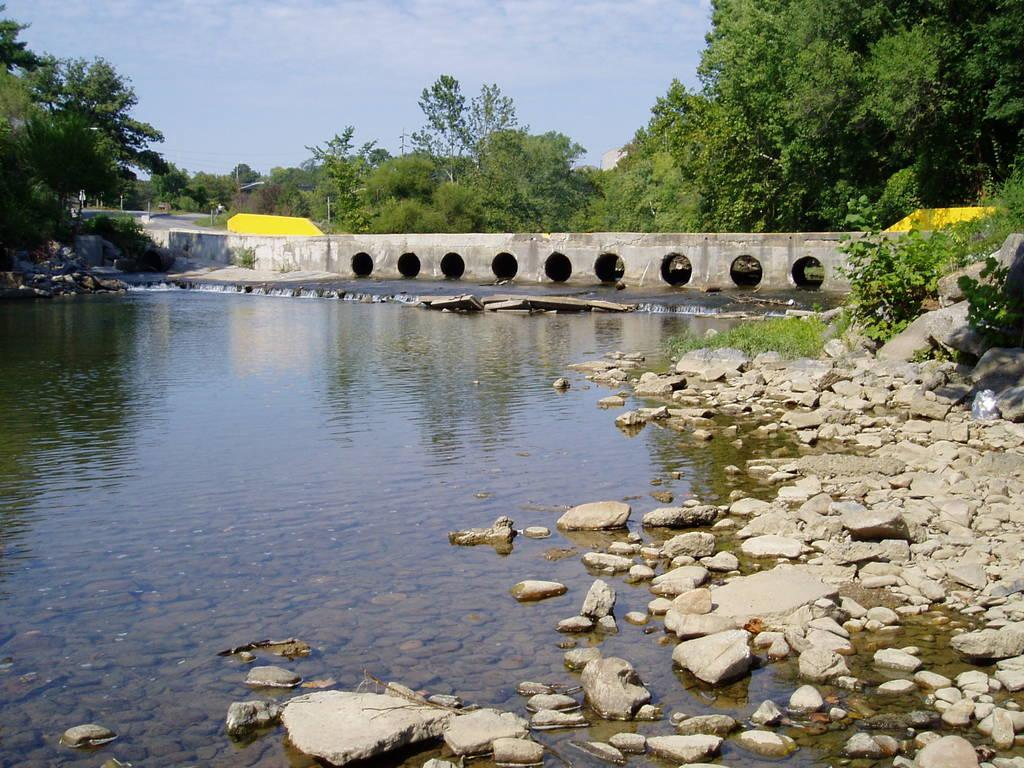What type of natural vegetation can be seen in the image? There are trees in the image. What body of water is visible in the image? There is water visible in the image. What type of structures can be seen in the image? There are poles in the image. What man-made feature is present in the image? There is a road in the image. What type of terrain is visible in the image? There are stones in the image. What is visible in the upper part of the image? The sky is visible in the image. Can you tell me how many rays are being pulled by the trees in the image? There are no rays present in the image, and trees do not have the ability to pull or push objects. 